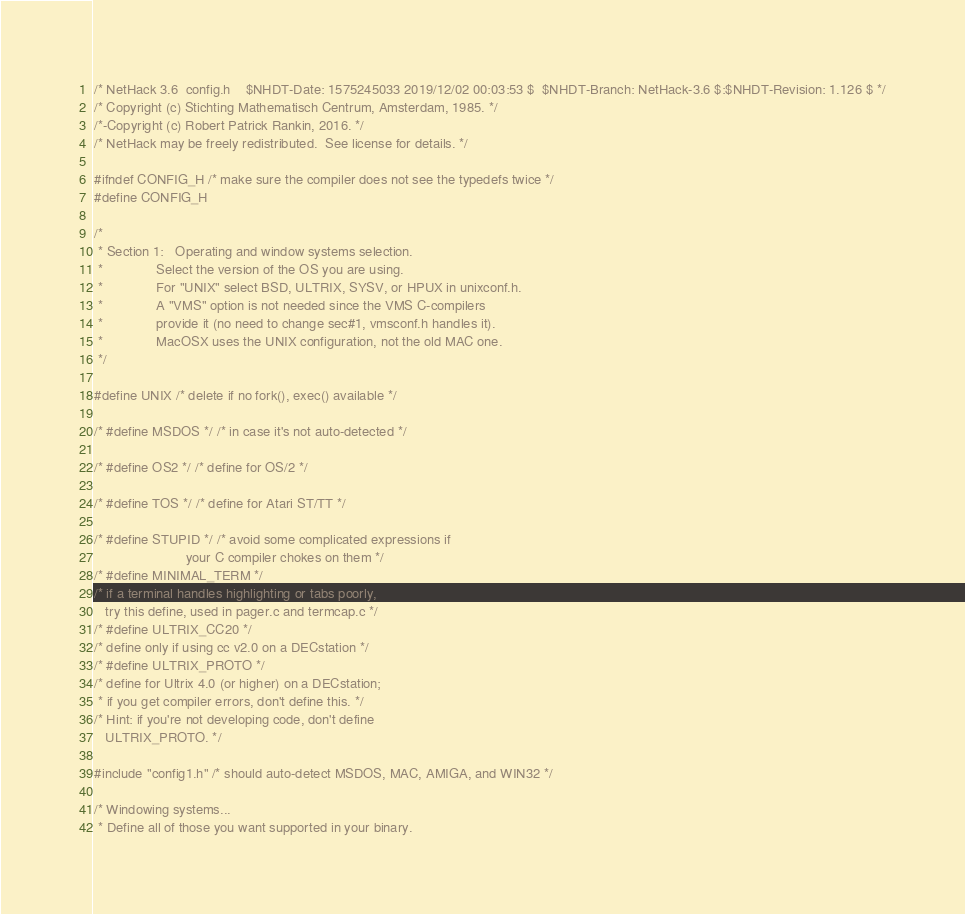<code> <loc_0><loc_0><loc_500><loc_500><_C_>/* NetHack 3.6	config.h	$NHDT-Date: 1575245033 2019/12/02 00:03:53 $  $NHDT-Branch: NetHack-3.6 $:$NHDT-Revision: 1.126 $ */
/* Copyright (c) Stichting Mathematisch Centrum, Amsterdam, 1985. */
/*-Copyright (c) Robert Patrick Rankin, 2016. */
/* NetHack may be freely redistributed.  See license for details. */

#ifndef CONFIG_H /* make sure the compiler does not see the typedefs twice */
#define CONFIG_H

/*
 * Section 1:   Operating and window systems selection.
 *              Select the version of the OS you are using.
 *              For "UNIX" select BSD, ULTRIX, SYSV, or HPUX in unixconf.h.
 *              A "VMS" option is not needed since the VMS C-compilers
 *              provide it (no need to change sec#1, vmsconf.h handles it).
 *              MacOSX uses the UNIX configuration, not the old MAC one.
 */

#define UNIX /* delete if no fork(), exec() available */

/* #define MSDOS */ /* in case it's not auto-detected */

/* #define OS2 */ /* define for OS/2 */

/* #define TOS */ /* define for Atari ST/TT */

/* #define STUPID */ /* avoid some complicated expressions if
                        your C compiler chokes on them */
/* #define MINIMAL_TERM */
/* if a terminal handles highlighting or tabs poorly,
   try this define, used in pager.c and termcap.c */
/* #define ULTRIX_CC20 */
/* define only if using cc v2.0 on a DECstation */
/* #define ULTRIX_PROTO */
/* define for Ultrix 4.0 (or higher) on a DECstation;
 * if you get compiler errors, don't define this. */
/* Hint: if you're not developing code, don't define
   ULTRIX_PROTO. */

#include "config1.h" /* should auto-detect MSDOS, MAC, AMIGA, and WIN32 */

/* Windowing systems...
 * Define all of those you want supported in your binary.</code> 